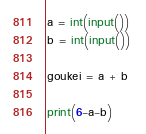Convert code to text. <code><loc_0><loc_0><loc_500><loc_500><_Python_>a = int(input())
b = int(input())

goukei = a + b 

print(6-a-b)</code> 